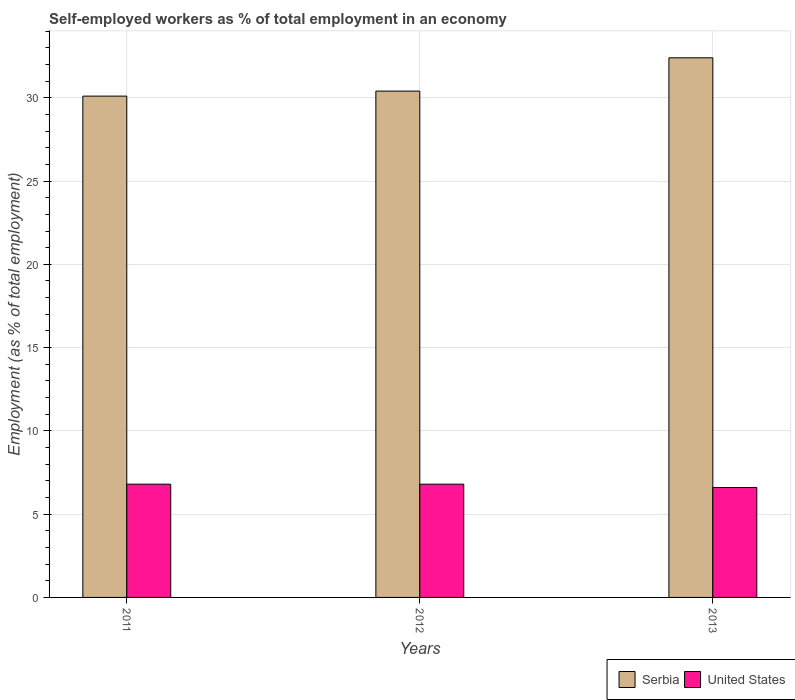How many different coloured bars are there?
Your response must be concise. 2. Are the number of bars per tick equal to the number of legend labels?
Your response must be concise. Yes. How many bars are there on the 3rd tick from the left?
Provide a succinct answer. 2. In how many cases, is the number of bars for a given year not equal to the number of legend labels?
Give a very brief answer. 0. What is the percentage of self-employed workers in Serbia in 2011?
Your response must be concise. 30.1. Across all years, what is the maximum percentage of self-employed workers in Serbia?
Your answer should be compact. 32.4. Across all years, what is the minimum percentage of self-employed workers in Serbia?
Offer a terse response. 30.1. In which year was the percentage of self-employed workers in United States minimum?
Your answer should be compact. 2013. What is the total percentage of self-employed workers in United States in the graph?
Make the answer very short. 20.2. What is the difference between the percentage of self-employed workers in Serbia in 2011 and the percentage of self-employed workers in United States in 2012?
Provide a short and direct response. 23.3. What is the average percentage of self-employed workers in United States per year?
Offer a very short reply. 6.73. In the year 2013, what is the difference between the percentage of self-employed workers in United States and percentage of self-employed workers in Serbia?
Your answer should be very brief. -25.8. In how many years, is the percentage of self-employed workers in Serbia greater than 31 %?
Ensure brevity in your answer.  1. What is the ratio of the percentage of self-employed workers in Serbia in 2011 to that in 2012?
Your response must be concise. 0.99. Is the percentage of self-employed workers in Serbia in 2011 less than that in 2012?
Offer a very short reply. Yes. Is the difference between the percentage of self-employed workers in United States in 2012 and 2013 greater than the difference between the percentage of self-employed workers in Serbia in 2012 and 2013?
Provide a succinct answer. Yes. What is the difference between the highest and the lowest percentage of self-employed workers in Serbia?
Your answer should be compact. 2.3. Is the sum of the percentage of self-employed workers in United States in 2011 and 2012 greater than the maximum percentage of self-employed workers in Serbia across all years?
Provide a succinct answer. No. What does the 2nd bar from the left in 2011 represents?
Offer a terse response. United States. What does the 1st bar from the right in 2011 represents?
Give a very brief answer. United States. Are all the bars in the graph horizontal?
Provide a succinct answer. No. What is the difference between two consecutive major ticks on the Y-axis?
Make the answer very short. 5. Does the graph contain any zero values?
Your answer should be very brief. No. Does the graph contain grids?
Make the answer very short. Yes. Where does the legend appear in the graph?
Ensure brevity in your answer.  Bottom right. How many legend labels are there?
Your answer should be very brief. 2. What is the title of the graph?
Make the answer very short. Self-employed workers as % of total employment in an economy. What is the label or title of the X-axis?
Make the answer very short. Years. What is the label or title of the Y-axis?
Make the answer very short. Employment (as % of total employment). What is the Employment (as % of total employment) in Serbia in 2011?
Offer a terse response. 30.1. What is the Employment (as % of total employment) in United States in 2011?
Your answer should be compact. 6.8. What is the Employment (as % of total employment) in Serbia in 2012?
Keep it short and to the point. 30.4. What is the Employment (as % of total employment) of United States in 2012?
Give a very brief answer. 6.8. What is the Employment (as % of total employment) in Serbia in 2013?
Provide a succinct answer. 32.4. What is the Employment (as % of total employment) in United States in 2013?
Ensure brevity in your answer.  6.6. Across all years, what is the maximum Employment (as % of total employment) of Serbia?
Offer a terse response. 32.4. Across all years, what is the maximum Employment (as % of total employment) of United States?
Offer a terse response. 6.8. Across all years, what is the minimum Employment (as % of total employment) in Serbia?
Offer a terse response. 30.1. Across all years, what is the minimum Employment (as % of total employment) in United States?
Your response must be concise. 6.6. What is the total Employment (as % of total employment) in Serbia in the graph?
Provide a succinct answer. 92.9. What is the total Employment (as % of total employment) in United States in the graph?
Your response must be concise. 20.2. What is the difference between the Employment (as % of total employment) of United States in 2011 and that in 2013?
Your answer should be compact. 0.2. What is the difference between the Employment (as % of total employment) of Serbia in 2011 and the Employment (as % of total employment) of United States in 2012?
Offer a terse response. 23.3. What is the difference between the Employment (as % of total employment) in Serbia in 2011 and the Employment (as % of total employment) in United States in 2013?
Your answer should be very brief. 23.5. What is the difference between the Employment (as % of total employment) of Serbia in 2012 and the Employment (as % of total employment) of United States in 2013?
Offer a terse response. 23.8. What is the average Employment (as % of total employment) in Serbia per year?
Give a very brief answer. 30.97. What is the average Employment (as % of total employment) of United States per year?
Offer a very short reply. 6.73. In the year 2011, what is the difference between the Employment (as % of total employment) of Serbia and Employment (as % of total employment) of United States?
Make the answer very short. 23.3. In the year 2012, what is the difference between the Employment (as % of total employment) in Serbia and Employment (as % of total employment) in United States?
Your answer should be very brief. 23.6. In the year 2013, what is the difference between the Employment (as % of total employment) in Serbia and Employment (as % of total employment) in United States?
Provide a short and direct response. 25.8. What is the ratio of the Employment (as % of total employment) in Serbia in 2011 to that in 2012?
Offer a terse response. 0.99. What is the ratio of the Employment (as % of total employment) in United States in 2011 to that in 2012?
Offer a terse response. 1. What is the ratio of the Employment (as % of total employment) in Serbia in 2011 to that in 2013?
Your answer should be compact. 0.93. What is the ratio of the Employment (as % of total employment) of United States in 2011 to that in 2013?
Ensure brevity in your answer.  1.03. What is the ratio of the Employment (as % of total employment) in Serbia in 2012 to that in 2013?
Offer a very short reply. 0.94. What is the ratio of the Employment (as % of total employment) of United States in 2012 to that in 2013?
Your response must be concise. 1.03. What is the difference between the highest and the second highest Employment (as % of total employment) of United States?
Offer a terse response. 0. What is the difference between the highest and the lowest Employment (as % of total employment) in Serbia?
Your answer should be compact. 2.3. 